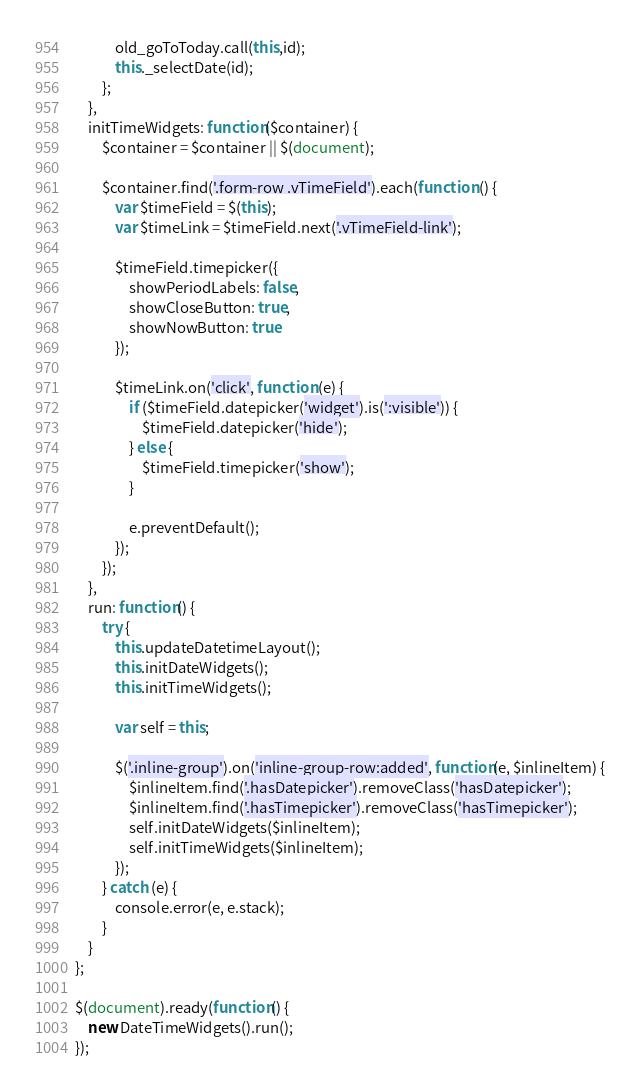<code> <loc_0><loc_0><loc_500><loc_500><_JavaScript_>            old_goToToday.call(this,id);
            this._selectDate(id);
        };
    },
    initTimeWidgets: function($container) {
        $container = $container || $(document);

        $container.find('.form-row .vTimeField').each(function () {
            var $timeField = $(this);
            var $timeLink = $timeField.next('.vTimeField-link');

            $timeField.timepicker({
                showPeriodLabels: false,
                showCloseButton: true,
                showNowButton: true
            });

            $timeLink.on('click', function (e) {
                if ($timeField.datepicker('widget').is(':visible')) {
                    $timeField.datepicker('hide');
                } else {
                    $timeField.timepicker('show');
                }

                e.preventDefault();
            });
        });
    },
    run: function() {
        try {
            this.updateDatetimeLayout();
            this.initDateWidgets();
            this.initTimeWidgets();

            var self = this;

            $('.inline-group').on('inline-group-row:added', function(e, $inlineItem) {
                $inlineItem.find('.hasDatepicker').removeClass('hasDatepicker');
                $inlineItem.find('.hasTimepicker').removeClass('hasTimepicker');
                self.initDateWidgets($inlineItem);
                self.initTimeWidgets($inlineItem);
            });
        } catch (e) {
            console.error(e, e.stack);
        }
    }
};

$(document).ready(function() {
    new DateTimeWidgets().run();
});
</code> 